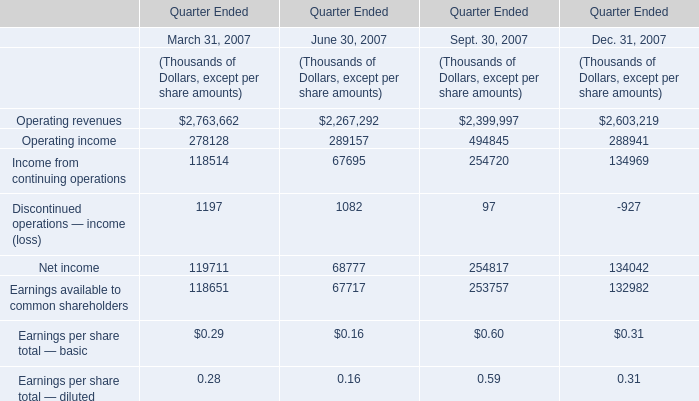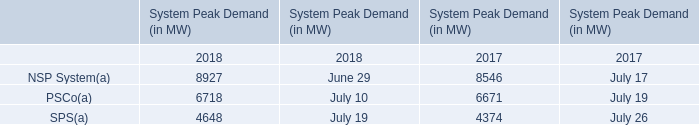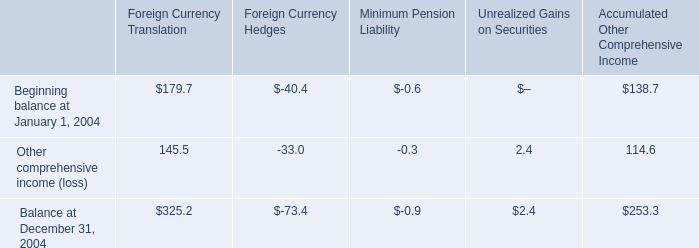What was the average value of the Income from continuing operations in the years where Income from continuing operations is positive? (in thousand) 
Computations: ((((118514 + 67695) + 254720) + 134969) / 3)
Answer: 191966.0. 